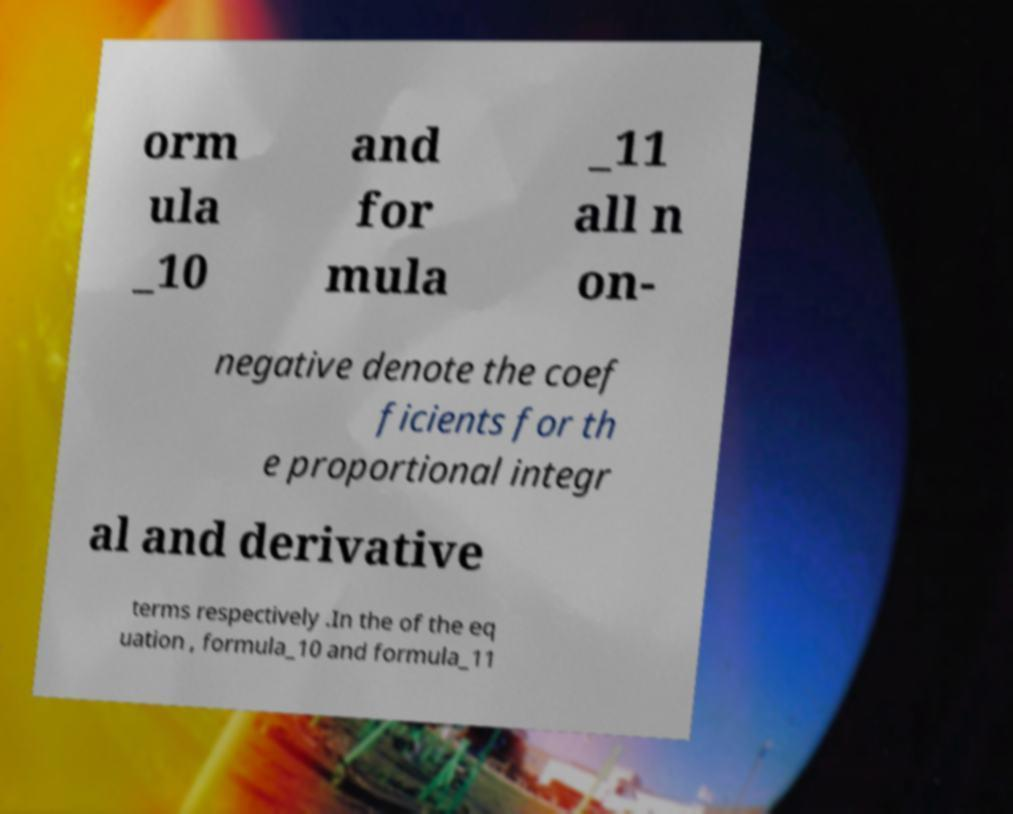Can you read and provide the text displayed in the image?This photo seems to have some interesting text. Can you extract and type it out for me? orm ula _10 and for mula _11 all n on- negative denote the coef ficients for th e proportional integr al and derivative terms respectively .In the of the eq uation , formula_10 and formula_11 